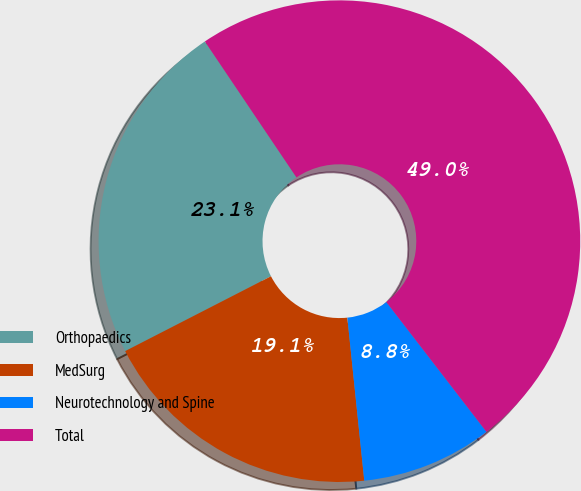Convert chart. <chart><loc_0><loc_0><loc_500><loc_500><pie_chart><fcel>Orthopaedics<fcel>MedSurg<fcel>Neurotechnology and Spine<fcel>Total<nl><fcel>23.11%<fcel>19.1%<fcel>8.81%<fcel>48.97%<nl></chart> 